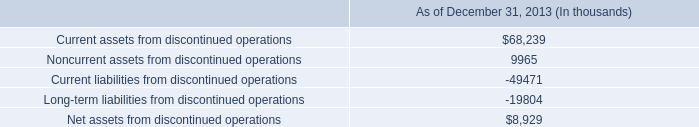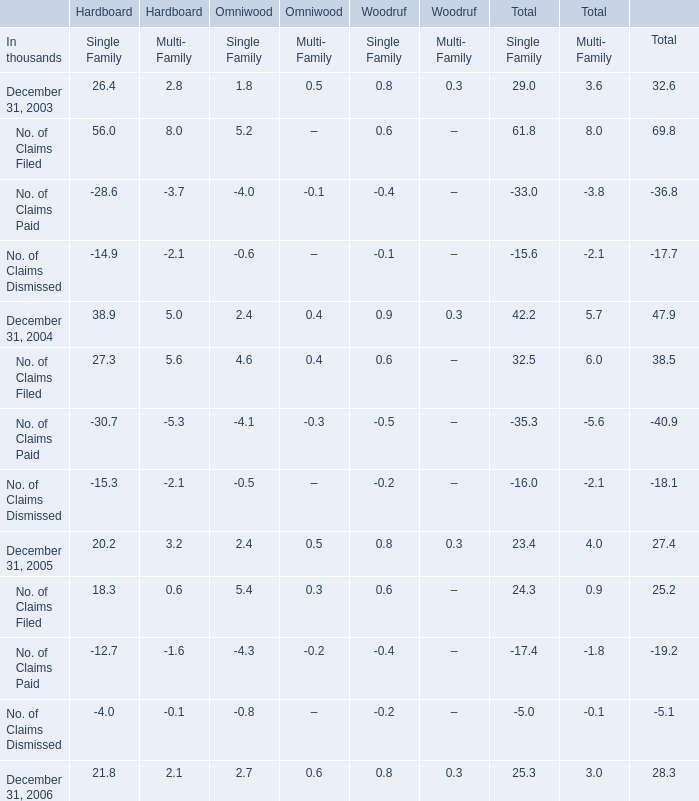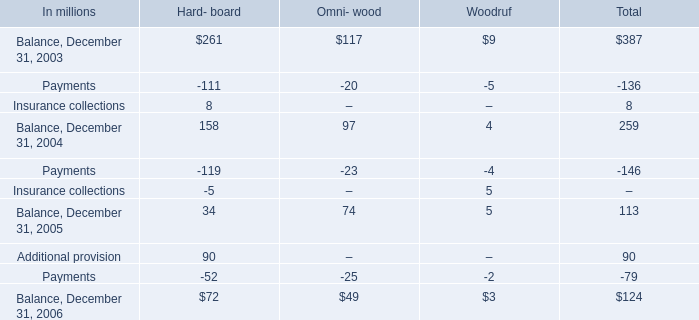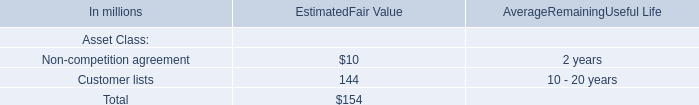In the year with largest amount of Payments, what's the sum of Hard- board? (in million) 
Computations: ((90 - 52) + 72)
Answer: 110.0. 